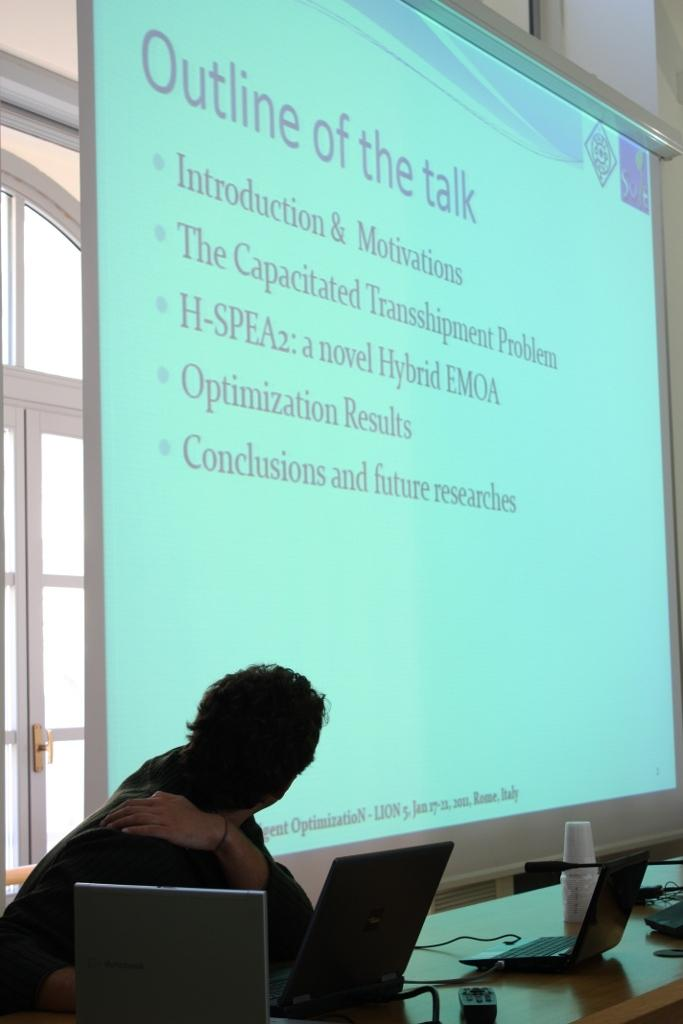<image>
Summarize the visual content of the image. A person at a laptop looking back at a projection screen displaying the outline of the talk. 